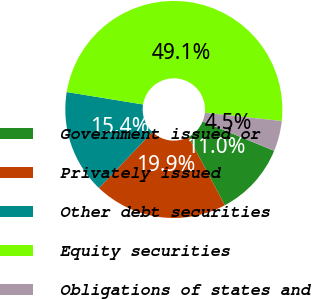Convert chart. <chart><loc_0><loc_0><loc_500><loc_500><pie_chart><fcel>Government issued or<fcel>Privately issued<fcel>Other debt securities<fcel>Equity securities<fcel>Obligations of states and<nl><fcel>10.99%<fcel>19.91%<fcel>15.45%<fcel>49.13%<fcel>4.53%<nl></chart> 